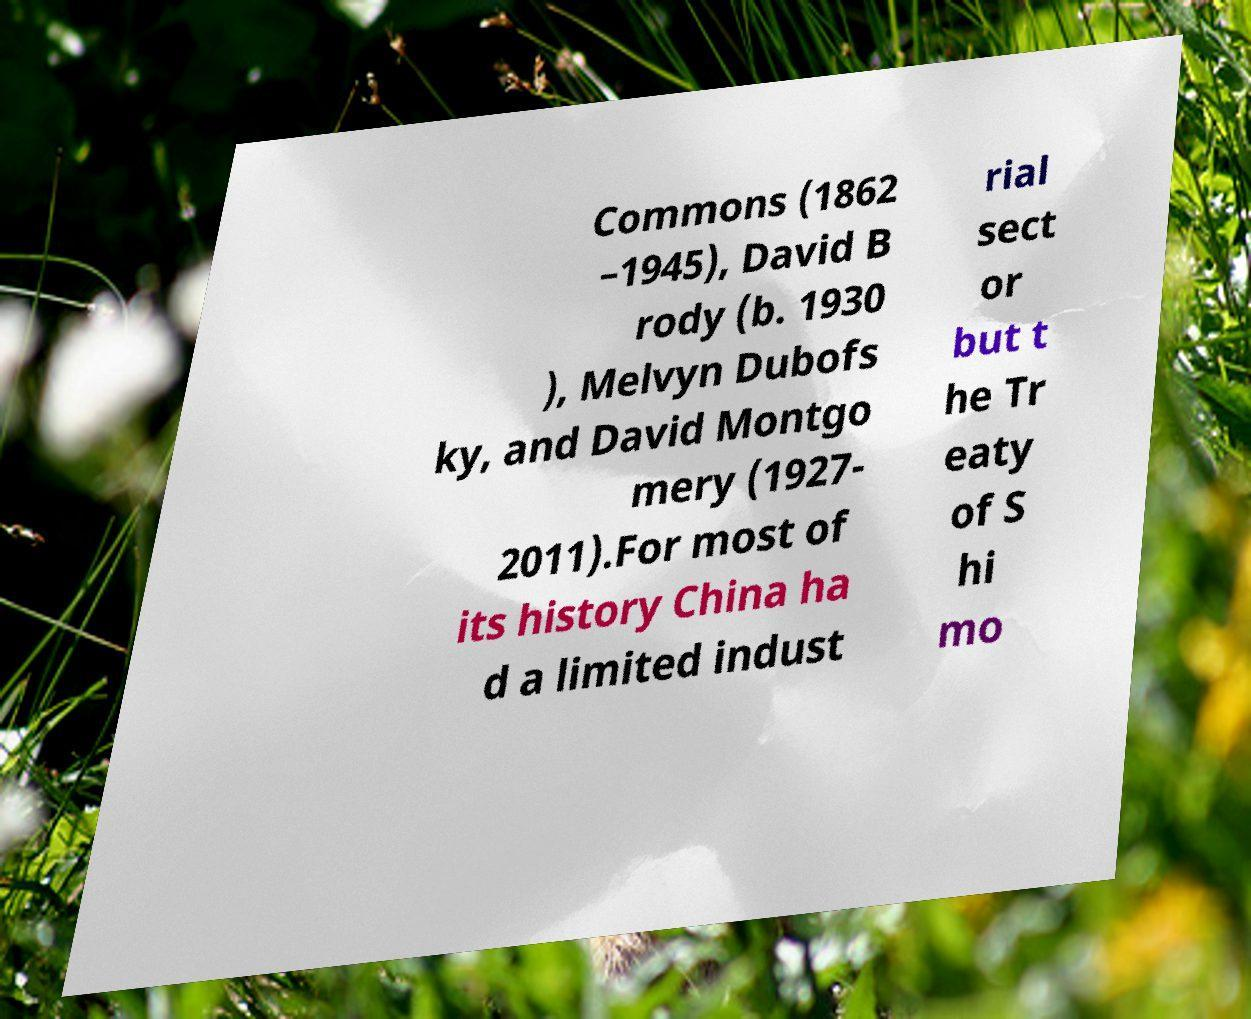I need the written content from this picture converted into text. Can you do that? Commons (1862 –1945), David B rody (b. 1930 ), Melvyn Dubofs ky, and David Montgo mery (1927- 2011).For most of its history China ha d a limited indust rial sect or but t he Tr eaty of S hi mo 